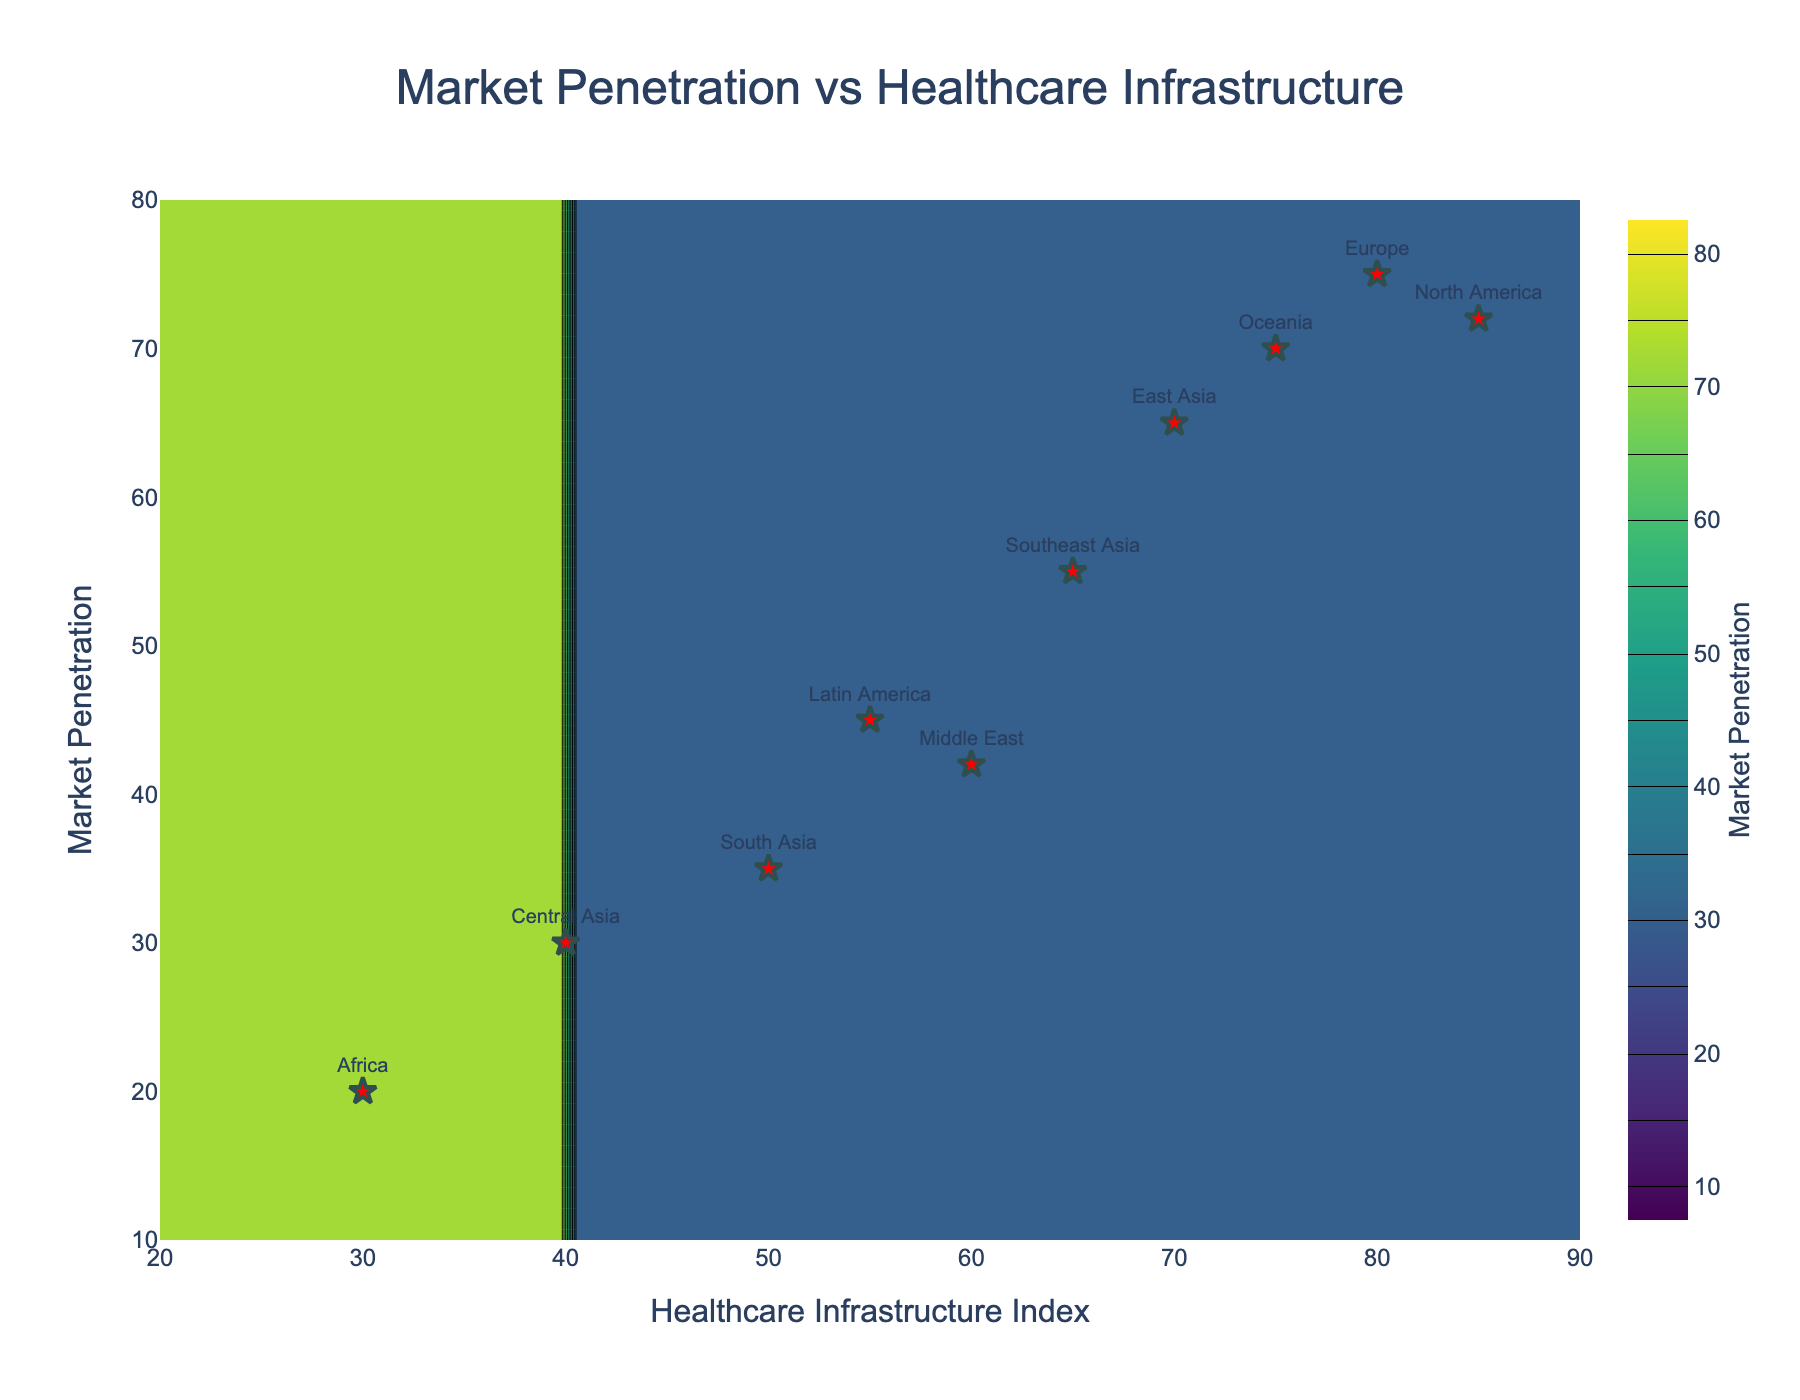How many data points are there on the scatter plot? By examining the figure, we can count the number of red star markers labeled with region names.
Answer: 10 What is the title of the figure? The title of the figure is typically located at the top of the plot and should be easy to read.
Answer: Market Penetration vs Healthcare Infrastructure Which region has the highest Market Penetration, and what is its value? By looking at the y-values of the red star markers, we can identify the highest value and the corresponding region.
Answer: Europe, 75 Which regions have Market Penetration values less than 50? By looking at the y-values of the red star markers, identify the regions with values below 50.
Answer: South Asia, Africa, Middle East, Central Asia What's the range of the Healthcare Infrastructure Index on the x-axis? The x-axis shows the range over which the Healthcare Infrastructure Index varies. Observing the minimum and maximum values on the x-axis gives the range.
Answer: 20 to 90 How many regions fall within a Healthcare Infrastructure Index range of 60 to 80? Count the number of red star markers that have x-values between 60 and 80.
Answer: 3 Compare the Market Penetration of North America and Latin America. Which region has higher penetration and by how much? Look at the y-values for North America and Latin America, then subtract the smaller value from the larger one to find the difference.
Answer: North America is higher by 27 What is the general trend between Healthcare Infrastructure Index and Market Penetration based on the scatter plot? Analyze the general direction and pattern of the scatter points.
Answer: Generally increasing Calculate the average Market Penetration for all the regions. Sum the Market Penetration values of all ten regions and divide by 10 to get the average.
Answer: 50 (steps: 72+75+65+35+20+45+42+70+55+30 = 509; 509 / 10 = 50.9) 